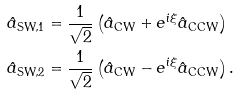Convert formula to latex. <formula><loc_0><loc_0><loc_500><loc_500>\hat { a } _ { \text {SW,1} } & = \frac { 1 } { \sqrt { 2 } } \left ( \hat { a } _ { \text {CW} } + e ^ { i \xi } \hat { a } _ { \text {CCW} } \right ) \\ \hat { a } _ { \text {SW,2} } & = \frac { 1 } { \sqrt { 2 } } \left ( \hat { a } _ { \text {CW} } - e ^ { i \xi } \hat { a } _ { \text {CCW} } \right ) .</formula> 